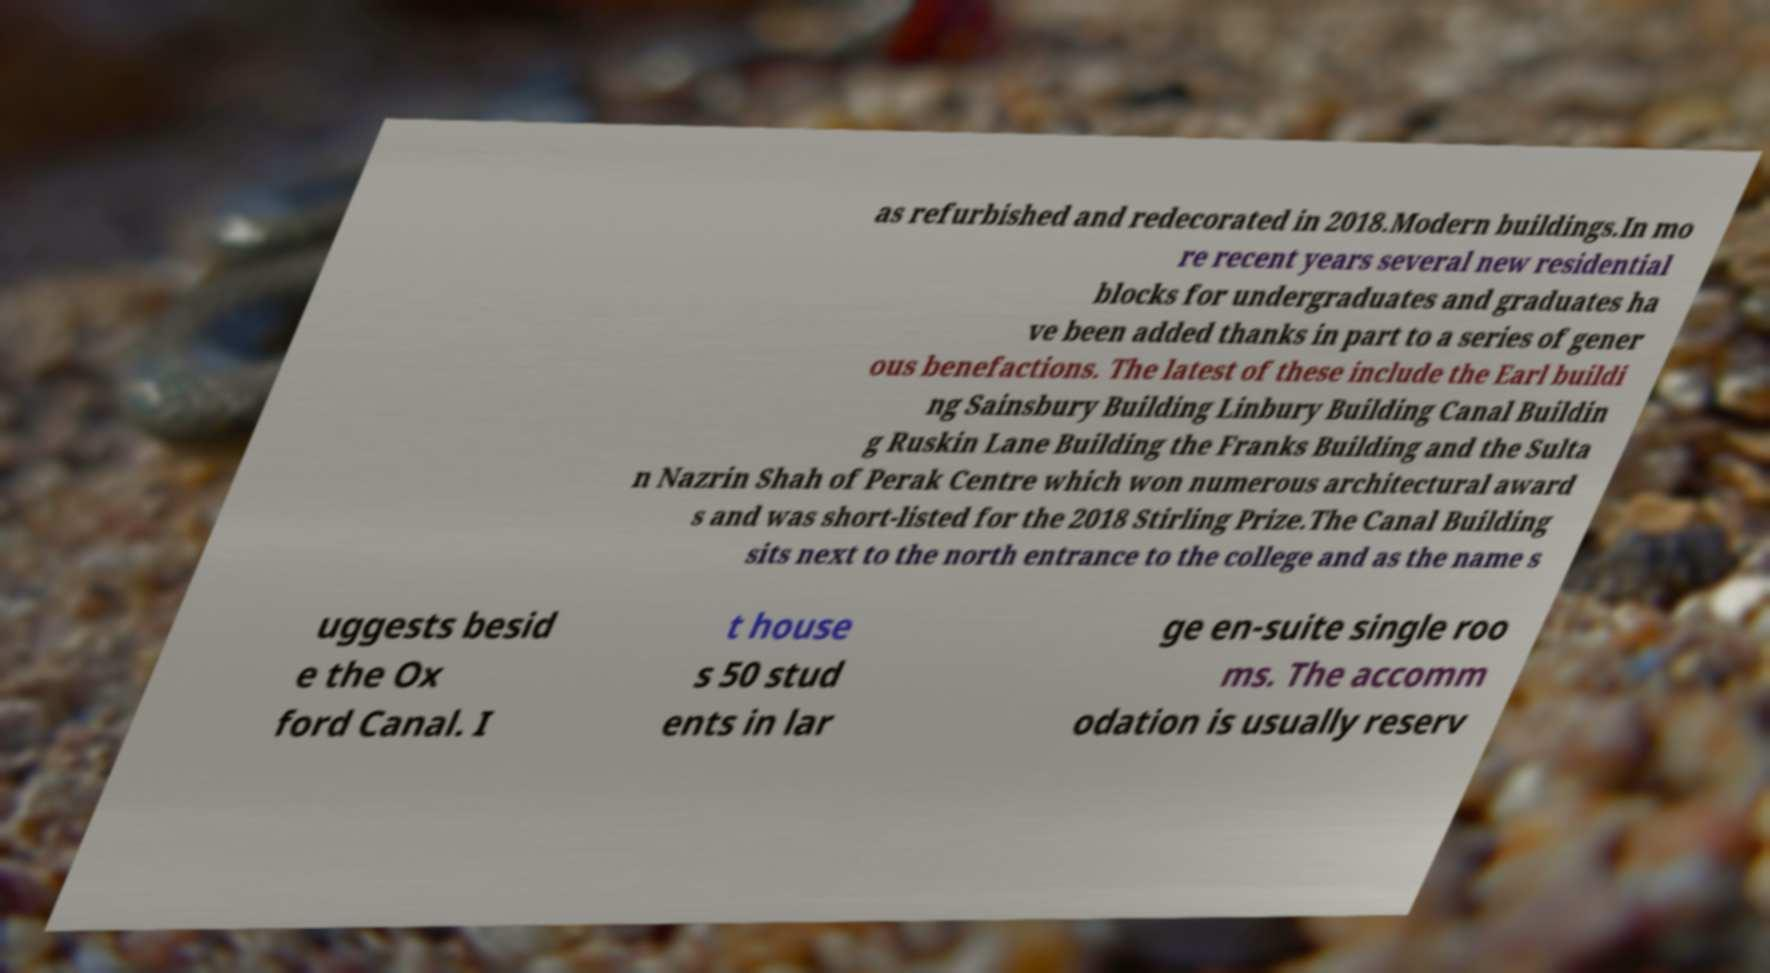I need the written content from this picture converted into text. Can you do that? as refurbished and redecorated in 2018.Modern buildings.In mo re recent years several new residential blocks for undergraduates and graduates ha ve been added thanks in part to a series of gener ous benefactions. The latest of these include the Earl buildi ng Sainsbury Building Linbury Building Canal Buildin g Ruskin Lane Building the Franks Building and the Sulta n Nazrin Shah of Perak Centre which won numerous architectural award s and was short-listed for the 2018 Stirling Prize.The Canal Building sits next to the north entrance to the college and as the name s uggests besid e the Ox ford Canal. I t house s 50 stud ents in lar ge en-suite single roo ms. The accomm odation is usually reserv 